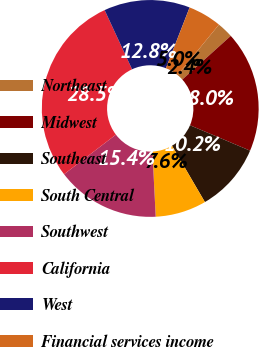Convert chart. <chart><loc_0><loc_0><loc_500><loc_500><pie_chart><fcel>Northeast<fcel>Midwest<fcel>Southeast<fcel>South Central<fcel>Southwest<fcel>California<fcel>West<fcel>Financial services income<nl><fcel>2.4%<fcel>18.04%<fcel>10.22%<fcel>7.61%<fcel>15.43%<fcel>28.47%<fcel>12.83%<fcel>5.01%<nl></chart> 